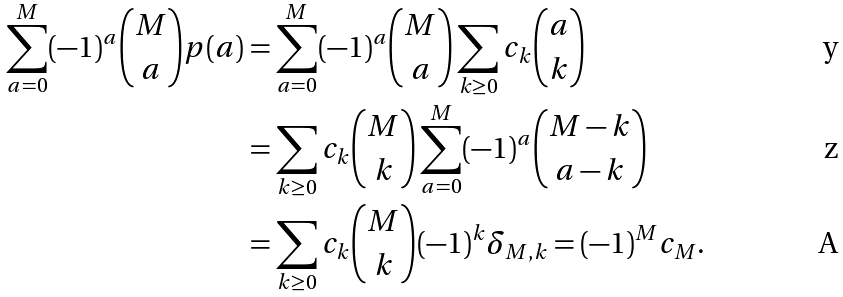<formula> <loc_0><loc_0><loc_500><loc_500>\sum _ { a = 0 } ^ { M } ( - 1 ) ^ { a } \binom { M } { a } p ( a ) & = \sum _ { a = 0 } ^ { M } ( - 1 ) ^ { a } \binom { M } { a } \sum _ { k \geq 0 } c _ { k } \binom { a } { k } \\ & = \sum _ { k \geq 0 } c _ { k } \binom { M } { k } \sum _ { a = 0 } ^ { M } ( - 1 ) ^ { a } \binom { M - k } { a - k } \\ & = \sum _ { k \geq 0 } c _ { k } \binom { M } { k } ( - 1 ) ^ { k } \delta _ { M , k } = ( - 1 ) ^ { M } c _ { M } .</formula> 